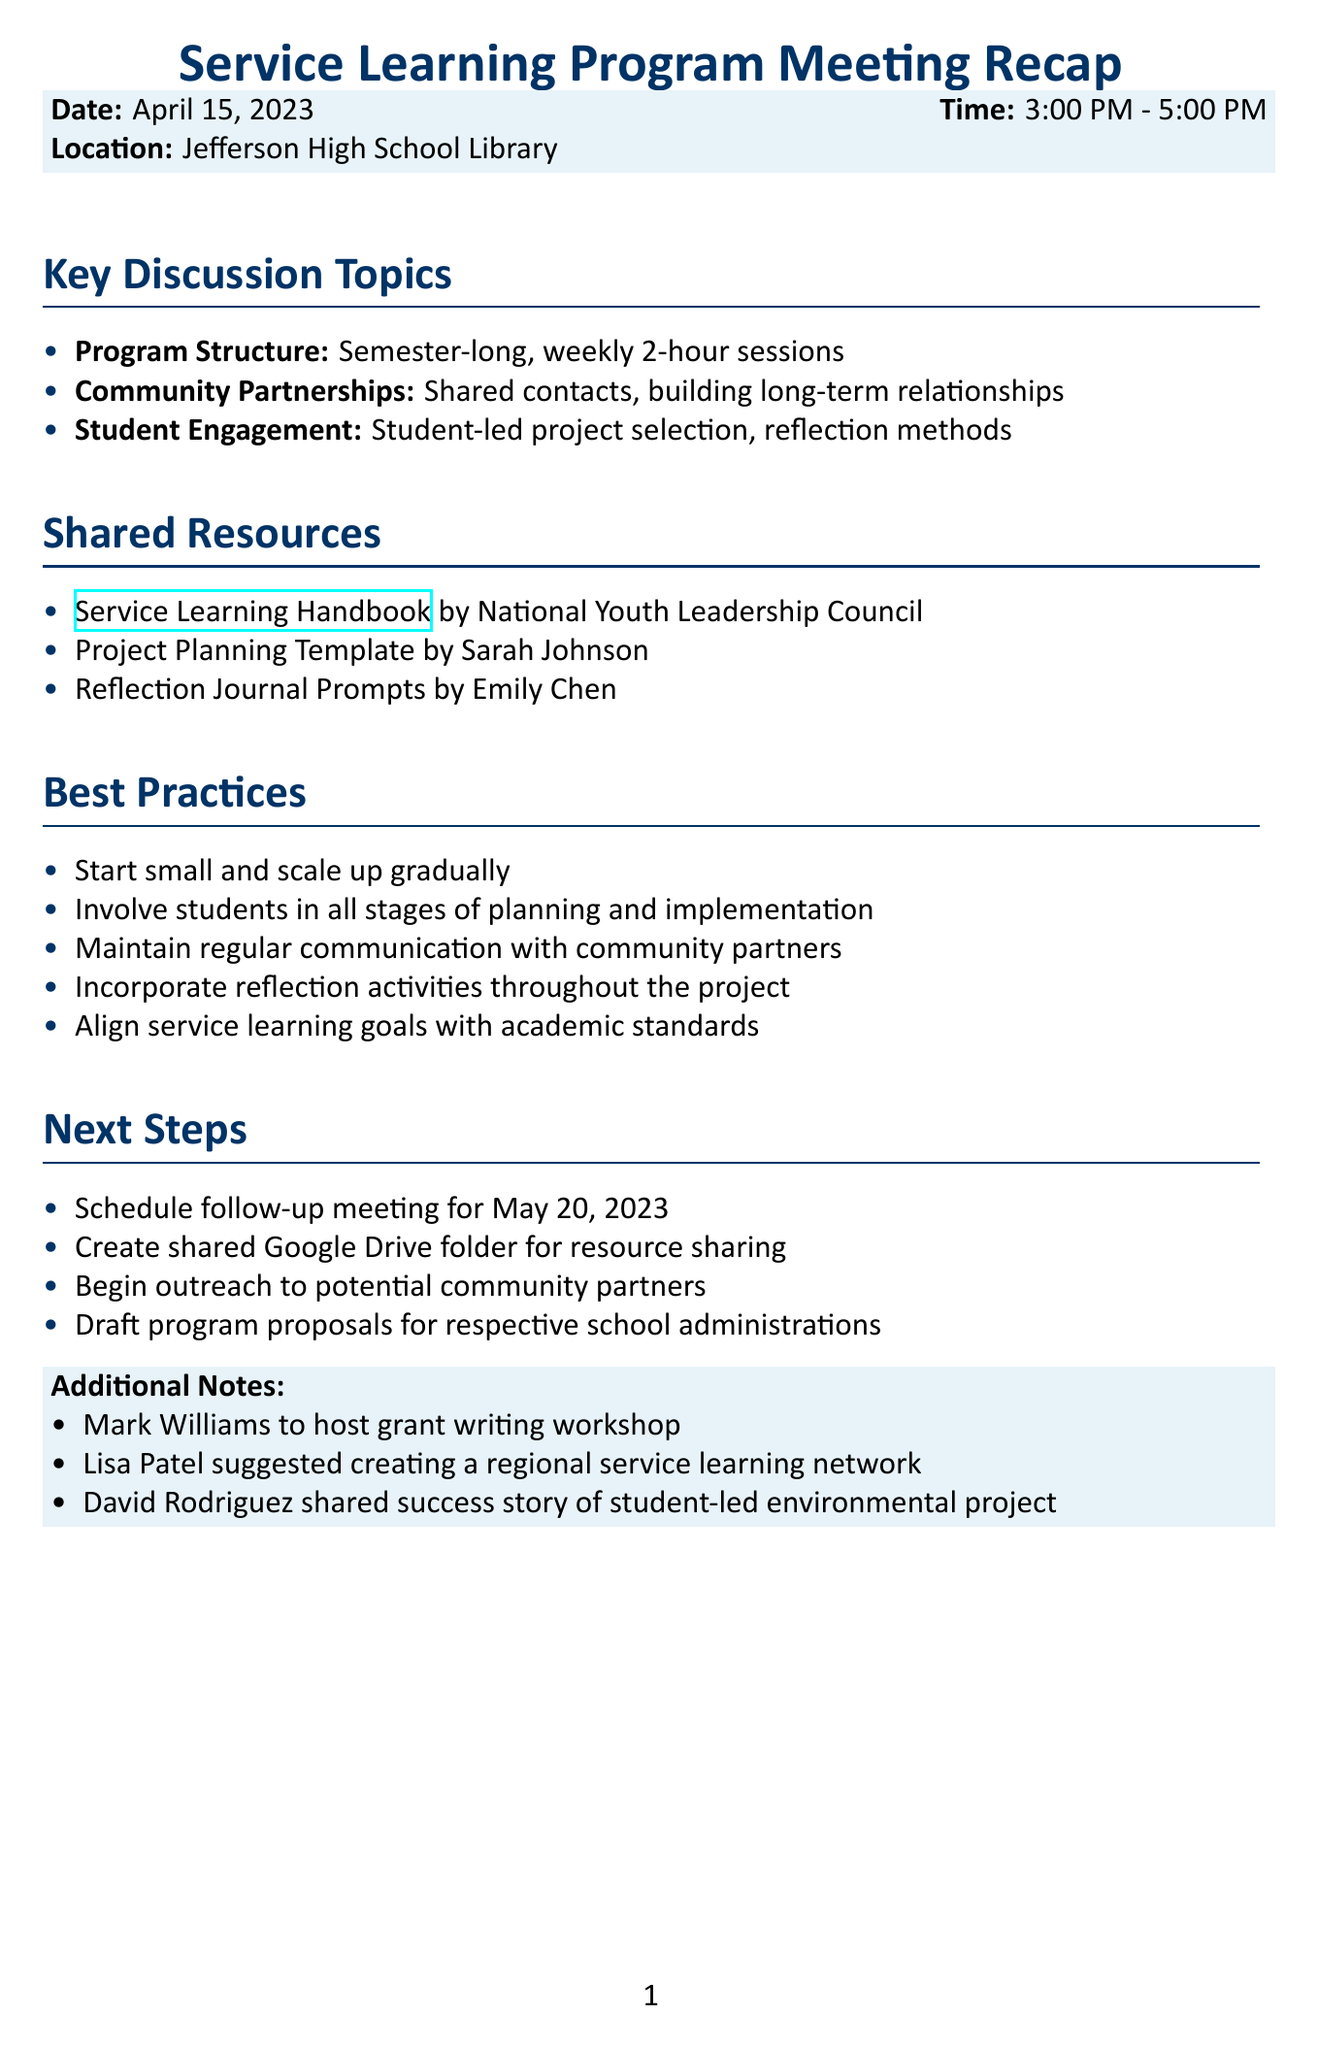What is the date of the meeting? The date of the meeting is explicitly stated in the document.
Answer: April 15, 2023 Who is the creator of the Project Planning Template? The document lists the creators of the shared resources, including the Project Planning Template.
Answer: Sarah Johnson What is the time duration of the program sessions? The meeting notes detail the structure of the program, including session duration.
Answer: 2 hours What community-related strategy was emphasized during the meeting? The discussion topics include community partnerships and strategies discussed therein.
Answer: Clear communication How many attendees were present at the meeting? The document lists the attendees, which can be counted.
Answer: 5 Which document contains reflection journal prompts? The shared resources section provides the names and sources of various resources.
Answer: Reflection Journal Prompts What is one of the best practices mentioned? The document lists several best practices that can be easily referenced.
Answer: Start small and scale up gradually When is the next follow-up meeting scheduled? The next steps section of the document provides details about the follow-up meeting.
Answer: May 20, 2023 